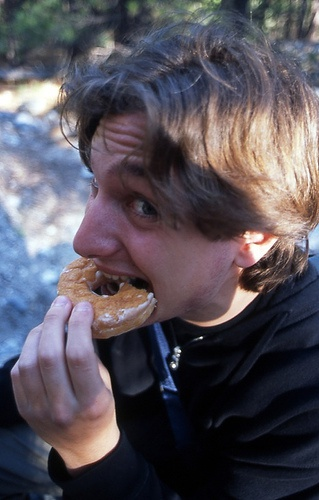Describe the objects in this image and their specific colors. I can see people in black and gray tones and donut in gray, darkgray, and tan tones in this image. 